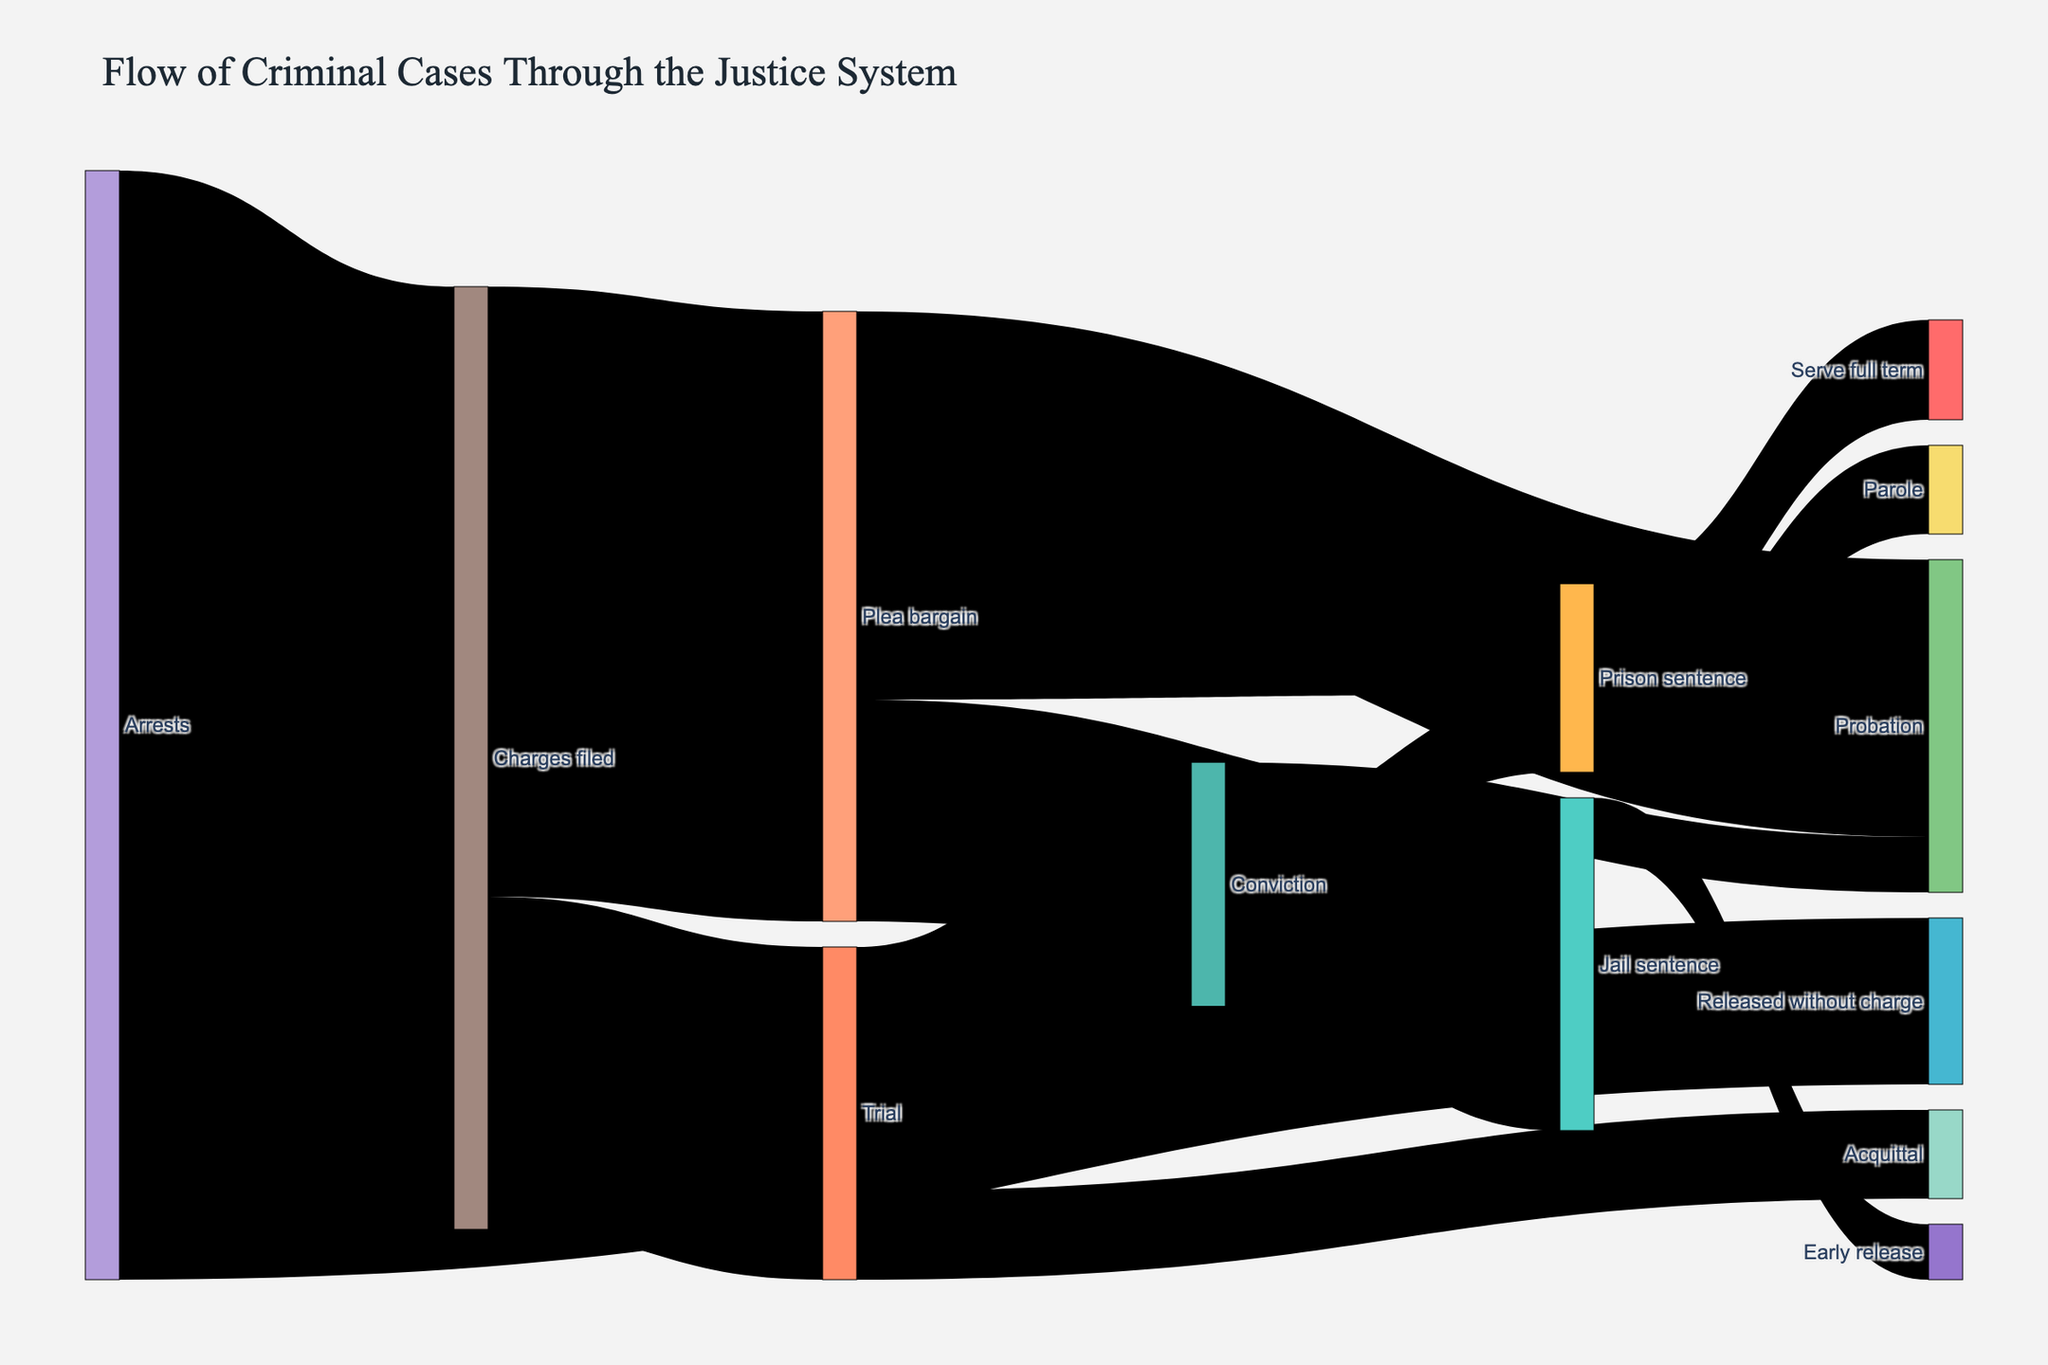what is the title of the Sankey diagram? The title of the diagram is usually located at the top center of the figure. By looking at this area, you can see that the title is "Flow of Criminal Cases Through the Justice System".
Answer: Flow of Criminal Cases Through the Justice System How many cases resulted in a plea bargain? Based on the flow from "Charges filed" to "Plea bargain", you can see the number associated with this transition. There are 55,000 cases that ended in a plea bargain.
Answer: 55,000 How many cases were acquitted after trial? By following the flow from "Trial" to "Acquittal", you will find the number associated with this transition. There are 8,000 cases that resulted in acquittal.
Answer: 8,000 What is the total number of cases that resulted in jail sentences from both plea bargains and convictions combined? To find the total, you need to add the values from the transitions "Plea bargain" to "Jail sentence" (20,000) and "Conviction" to "Jail sentence" (10,000). Adding these gives 20,000 + 10,000 = 30,000.
Answer: 30,000 Which pathway has the highest number of cases, and how many cases does it involve? By examining all the flows, the transition from "Charges filed" to "Plea bargain" shows the highest number of cases, which is 55,000.
Answer: Charges filed to Plea bargain, 55,000 What percentage of cases were released without charge out of the total number of arrests? First, find the total number of arrests which is the sum of "Released without charge" (15,000) and "Charges filed" (85,000). The total arrests are 100,000. Then, the percentage is (15,000/100,000) * 100 = 15%.
Answer: 15% How many cases served a full term in prison? Look at the transition from "Prison sentence" to "Serve full term". The number of cases is 9,000.
Answer: 9,000 Compare the number of cases that went to trial versus those that resulted in a plea bargain. Which is more and by how much? The number of cases that went to "Trial" is 30,000 and those that resulted in a "Plea bargain" is 55,000. The difference is 55,000 - 30,000 = 25,000 more cases resulted in a plea bargain.
Answer: Plea bargain is more by 25,000 How many cases were given probation as a result of a conviction or plea bargain? Add the number of cases from "Plea bargain" to "Probation" (25,000) and "Conviction" to "Probation" (5,000). The total is 25,000 + 5,000 = 30,000.
Answer: 30,000 What is the ratio of convictions to acquittals in trials? The number of convictions from trials is 22,000 and the number of acquittals is 8,000. The ratio is 22,000:8,000 or simplified as 22:8 = 11:4.
Answer: 11:4 